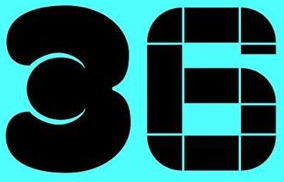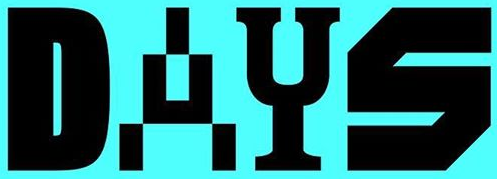Identify the words shown in these images in order, separated by a semicolon. 36; DAYS 